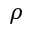Convert formula to latex. <formula><loc_0><loc_0><loc_500><loc_500>\rho</formula> 